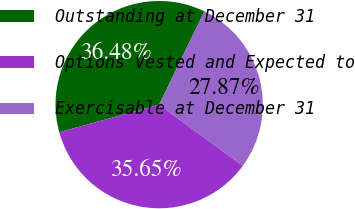Convert chart to OTSL. <chart><loc_0><loc_0><loc_500><loc_500><pie_chart><fcel>Outstanding at December 31<fcel>Options Vested and Expected to<fcel>Exercisable at December 31<nl><fcel>36.48%<fcel>35.65%<fcel>27.87%<nl></chart> 